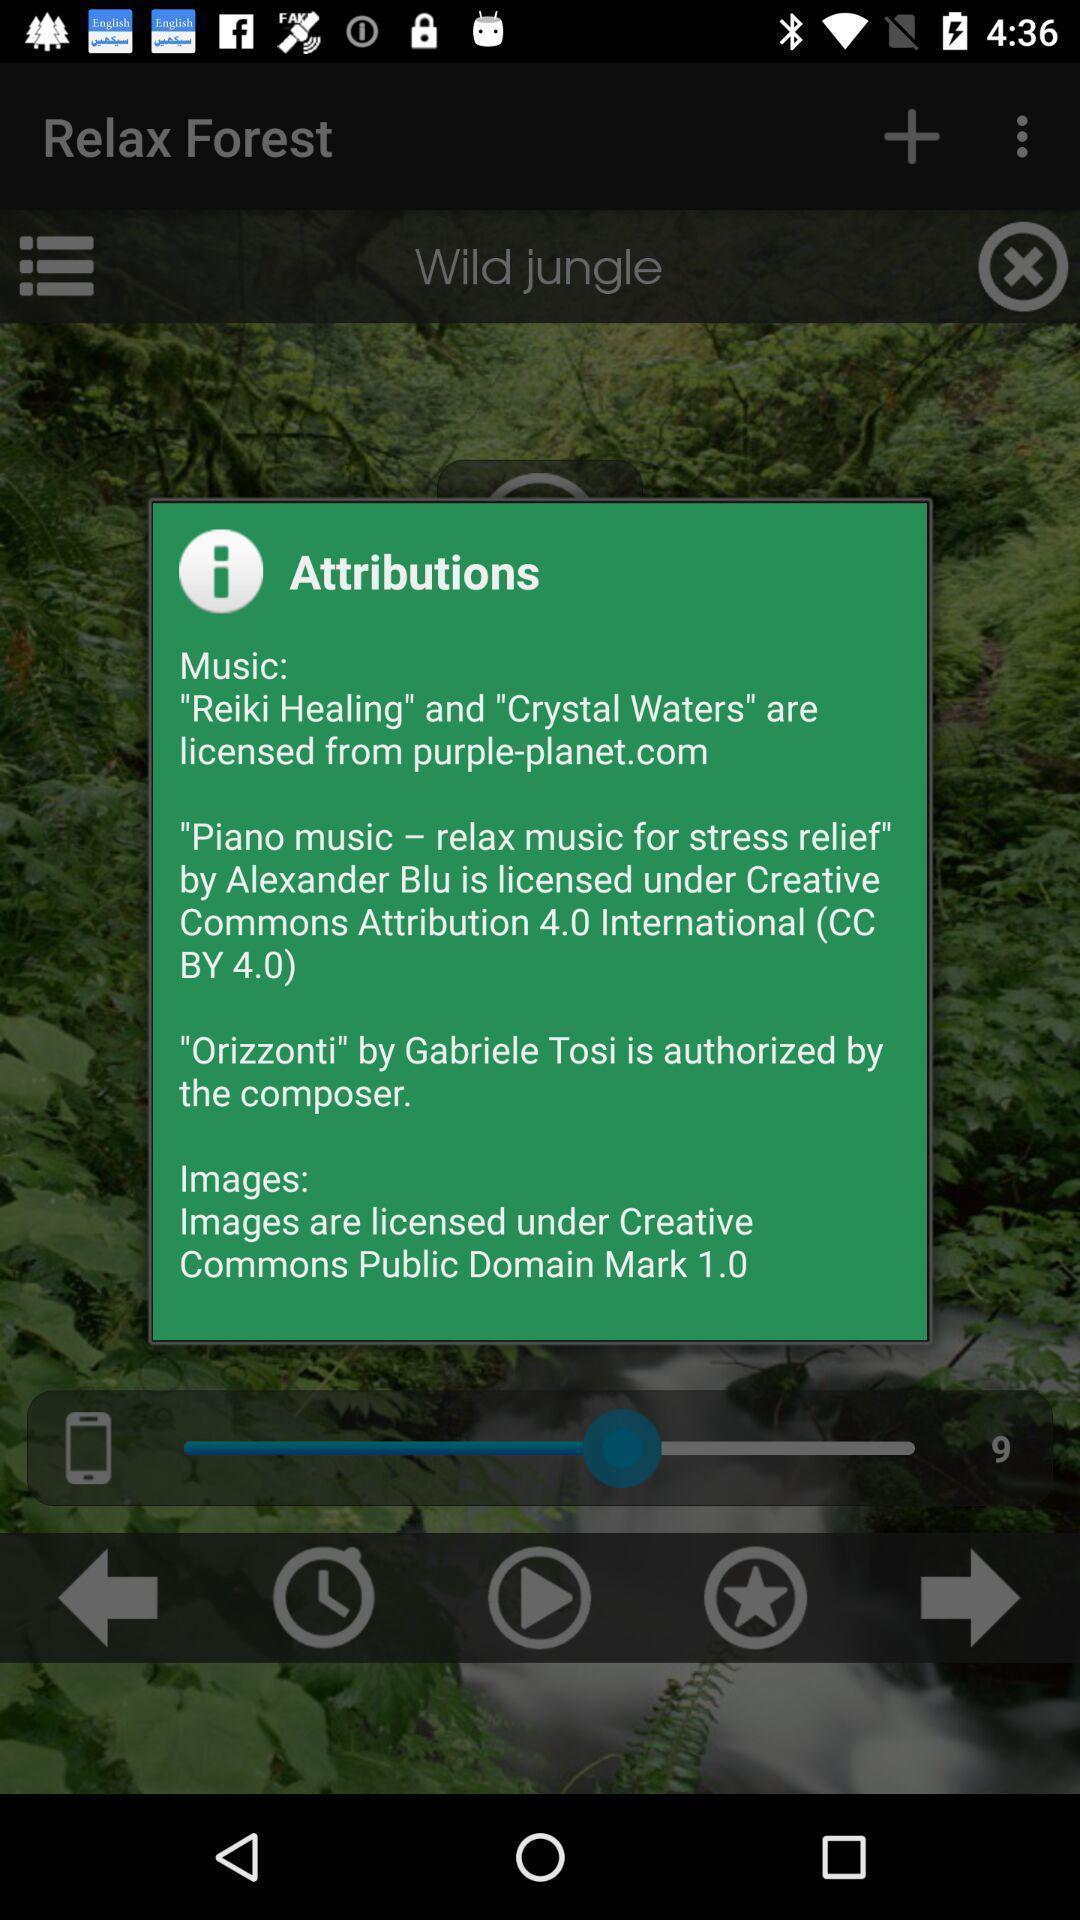Give me a narrative description of this picture. Pop-up showing details of the music. 